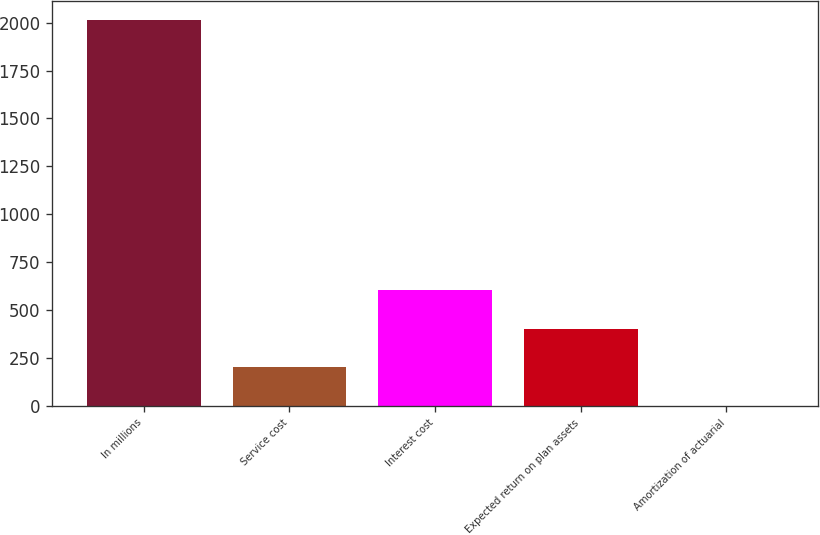<chart> <loc_0><loc_0><loc_500><loc_500><bar_chart><fcel>In millions<fcel>Service cost<fcel>Interest cost<fcel>Expected return on plan assets<fcel>Amortization of actuarial<nl><fcel>2012<fcel>202.1<fcel>604.3<fcel>403.2<fcel>1<nl></chart> 